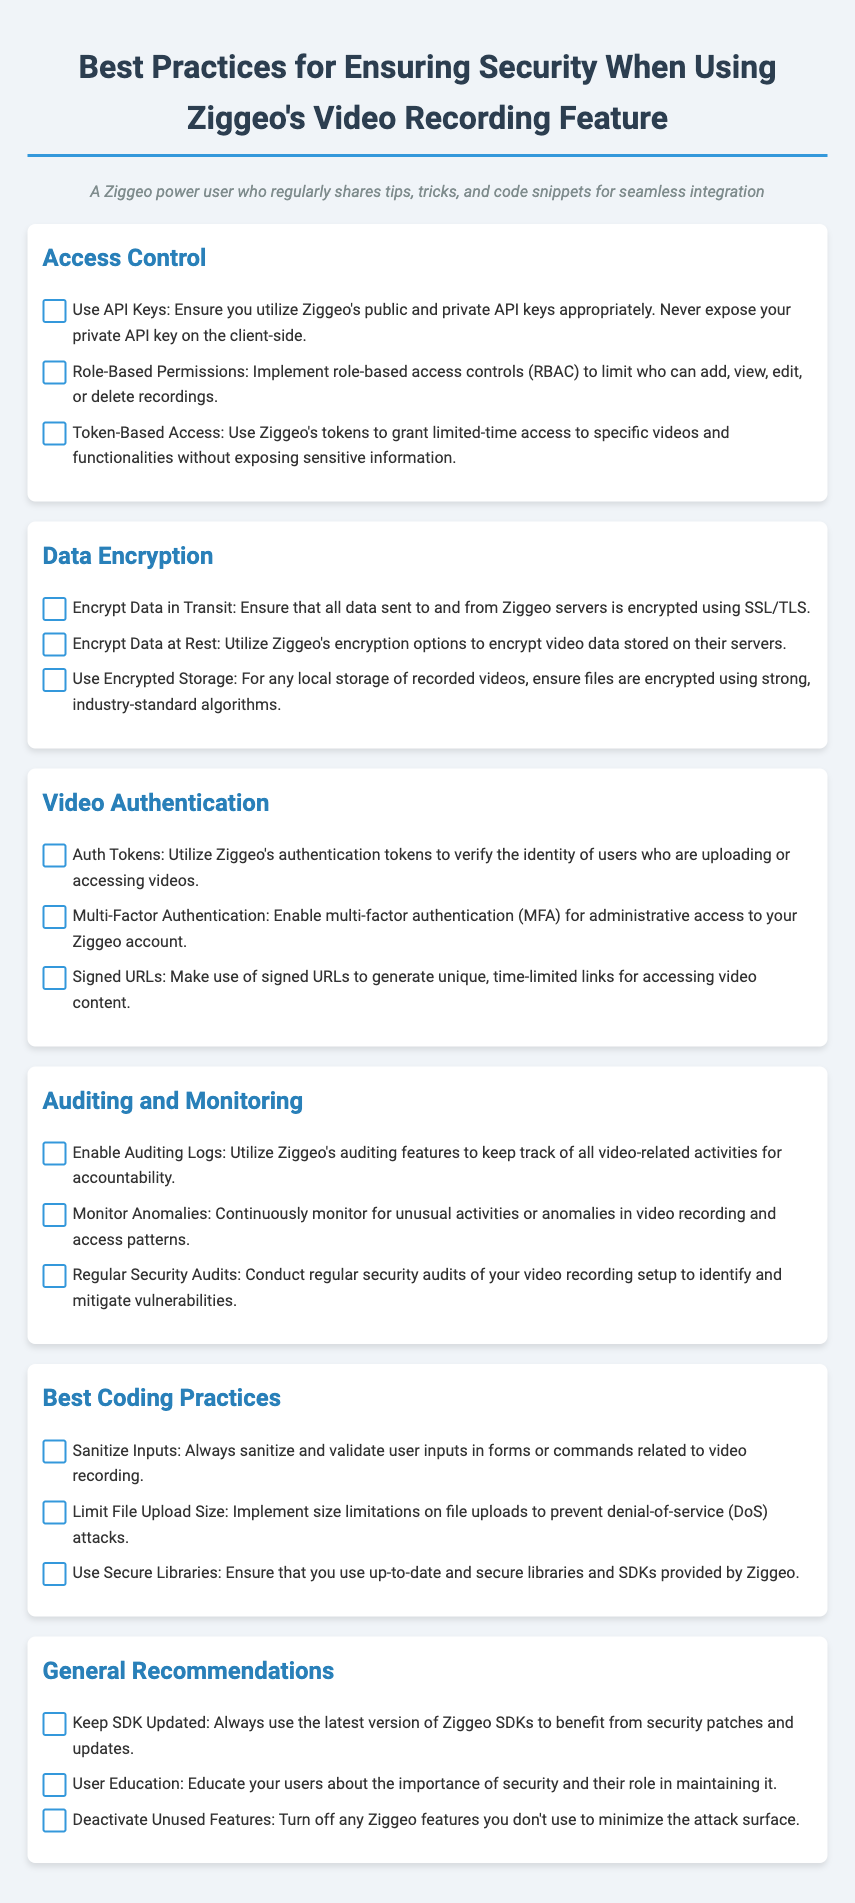What is the first category in the checklist? The first category listed in the document is "Access Control."
Answer: Access Control How many items are listed under "Data Encryption"? The document lists three items under the "Data Encryption" section.
Answer: 3 What type of authentication is recommended for administrative access? The checklist recommends enabling multi-factor authentication for administrative access.
Answer: Multi-Factor Authentication What should be monitored continuously according to the best practices? According to the checklist, unusual activities or anomalies in video recording and access patterns should be monitored continuously.
Answer: Unusual activities What is the suggestion for user education? The document suggests educating users about the importance of security and their role in maintaining it.
Answer: User education 